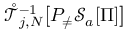<formula> <loc_0><loc_0><loc_500><loc_500>\mathring { \mathcal { T } } _ { j , N } ^ { - 1 } \left [ P _ { \neq } \mathcal { S } _ { a } [ \Pi ] \right ]</formula> 